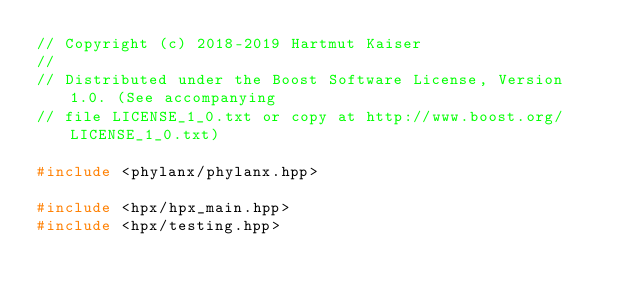<code> <loc_0><loc_0><loc_500><loc_500><_C++_>// Copyright (c) 2018-2019 Hartmut Kaiser
//
// Distributed under the Boost Software License, Version 1.0. (See accompanying
// file LICENSE_1_0.txt or copy at http://www.boost.org/LICENSE_1_0.txt)

#include <phylanx/phylanx.hpp>

#include <hpx/hpx_main.hpp>
#include <hpx/testing.hpp>
</code> 